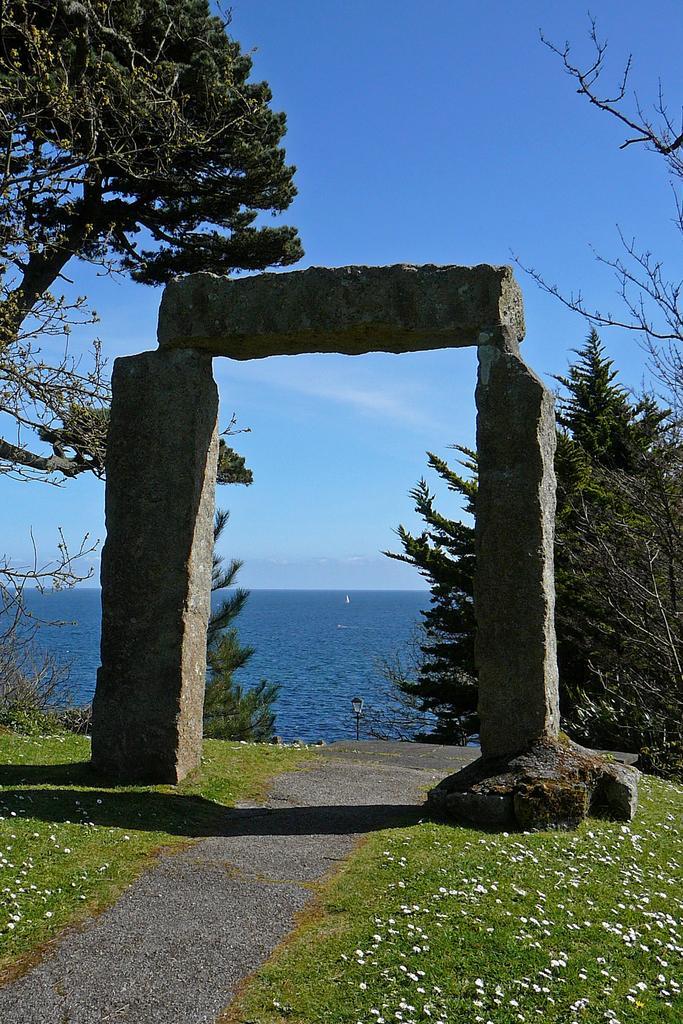Can you describe this image briefly? In this image there is an arch made up of stone. On both there are trees, grassland. In the background there is water body. The sky is clear. 